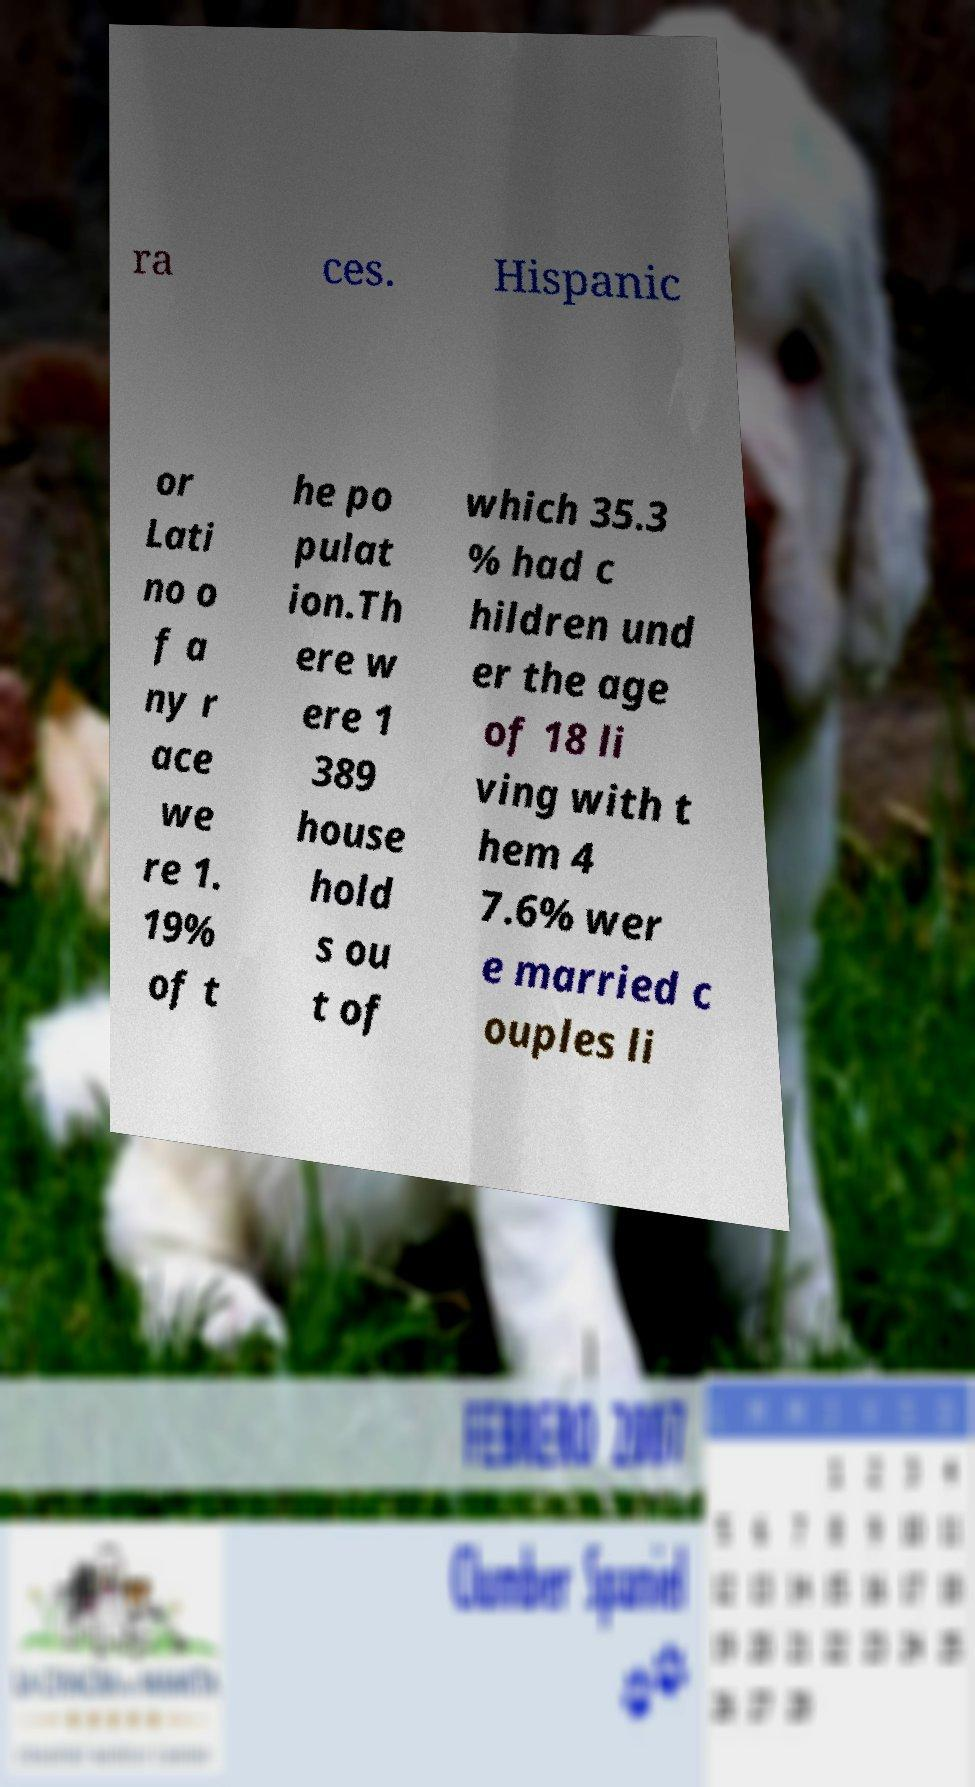Please identify and transcribe the text found in this image. ra ces. Hispanic or Lati no o f a ny r ace we re 1. 19% of t he po pulat ion.Th ere w ere 1 389 house hold s ou t of which 35.3 % had c hildren und er the age of 18 li ving with t hem 4 7.6% wer e married c ouples li 